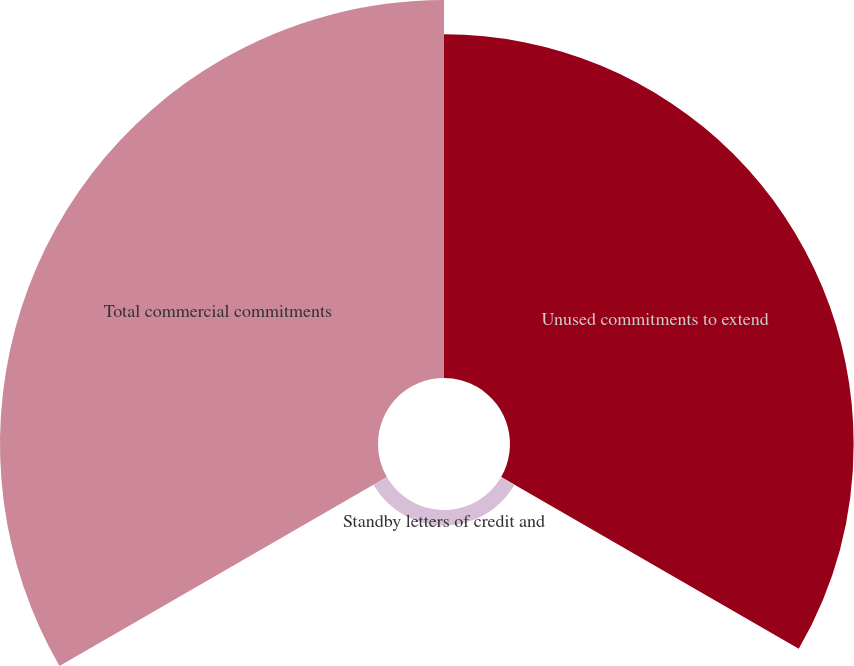<chart> <loc_0><loc_0><loc_500><loc_500><pie_chart><fcel>Unused commitments to extend<fcel>Standby letters of credit and<fcel>Total commercial commitments<nl><fcel>46.62%<fcel>2.1%<fcel>51.28%<nl></chart> 